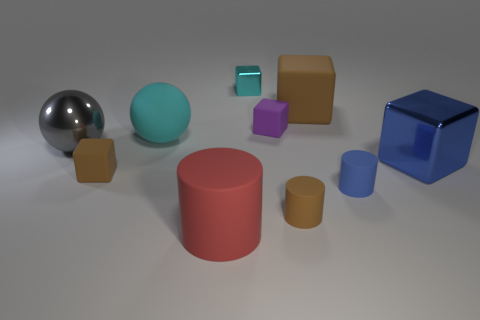There is a big metal object that is right of the purple matte object; is it the same shape as the tiny brown matte object that is to the right of the small purple rubber thing? No, they are not the same shape. The big metal object to the right of the purple matte one is a sphere, whereas the tiny brown matte object to the right of the small purple rubber item is a cube. 